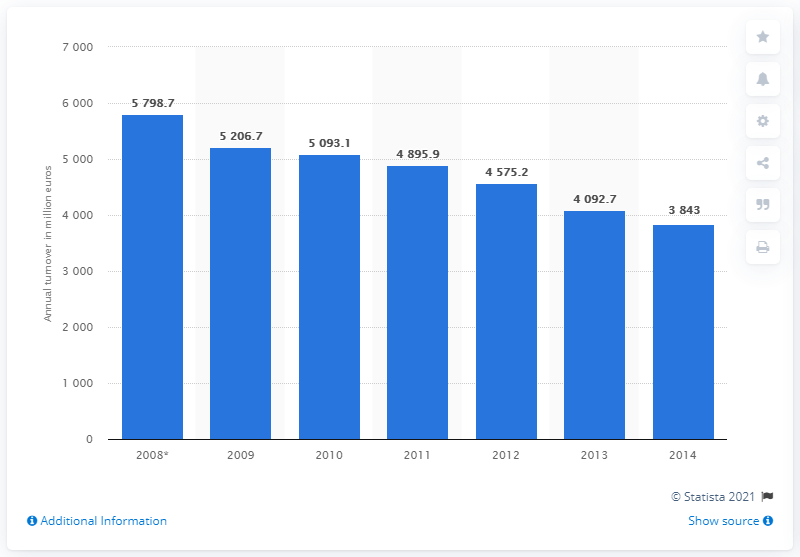Highlight a few significant elements in this photo. In 2008, the turnover of the Czech telecommunications industry was 5798.7 million. 